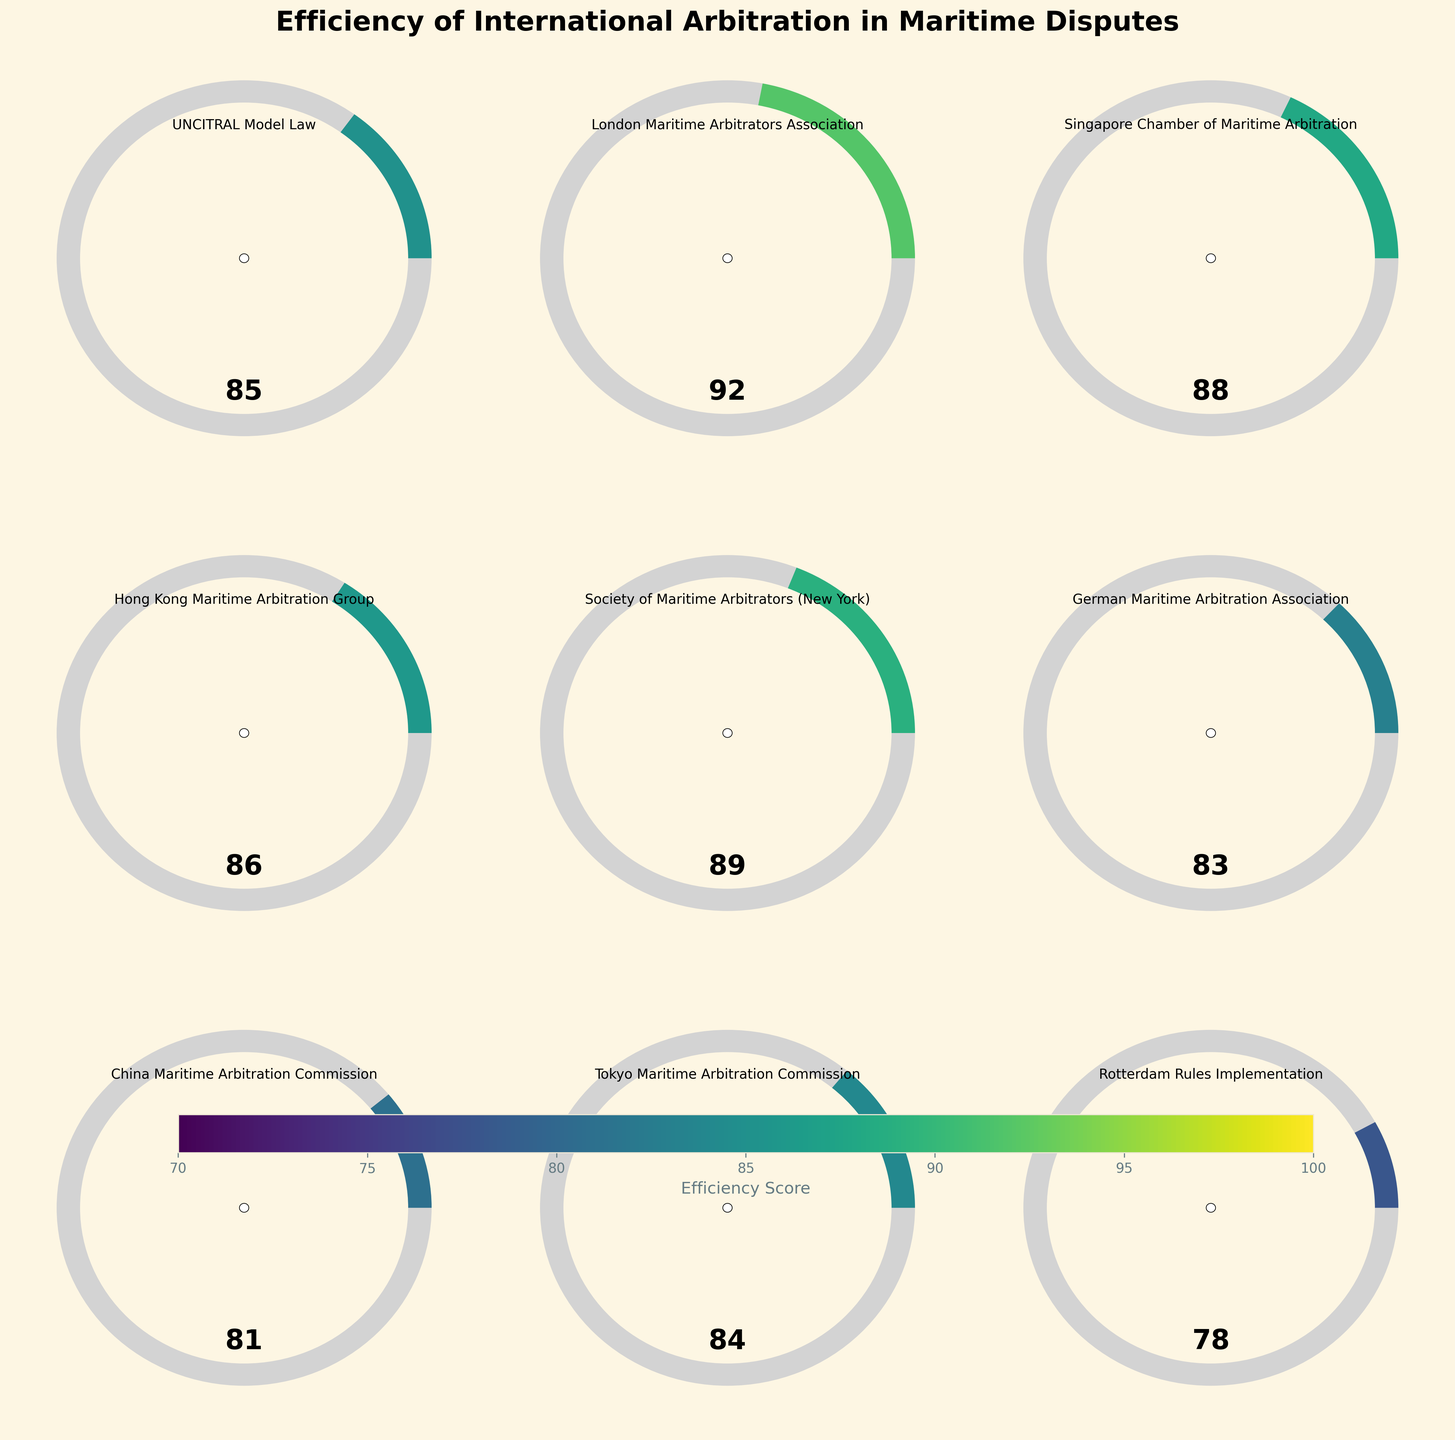What is the highest efficiency score in the figure? The London Maritime Arbitrators Association has the highest efficiency score. It is indicated by a value of 92 in one of the gauge charts.
Answer: 92 Which category has the lowest efficiency score? The Rotterdam Rules Implementation category has the lowest efficiency score, indicated by a value of 78 in its gauge chart.
Answer: Rotterdam Rules Implementation What is the title of the figure? The title of the figure is displayed at the top and reads "Efficiency of International Arbitration in Maritime Disputes".
Answer: Efficiency of International Arbitration in Maritime Disputes Which two categories have efficiency scores closest to each other? The efficiency scores for the Hong Kong Maritime Arbitration Group and the UNCITRAL Model Law are closest to each other, with scores of 86 and 85 respectively.
Answer: Hong Kong Maritime Arbitration Group, UNCITRAL Model Law What is the average efficiency score across all categories? Add all the efficiency scores (85 + 92 + 88 + 86 + 89 + 83 + 81 + 84 + 78) which equals 766, then divide by the number of categories (9) to get the average: 766 / 9 ≈ 85.11.
Answer: 85.11 How many categories have an efficiency score above 85? Count the number of gauge charts with a score greater than 85. They are: London Maritime Arbitrators Association (92), Singapore Chamber of Maritime Arbitration (88), Hong Kong Maritime Arbitration Group (86), and Society of Maritime Arbitrators (New York) (89).
Answer: 4 Which categories have an efficiency score of less than 80? Identify the gauge chart with scores below 80. The Rotterdam Rules Implementation has a score of 78.
Answer: Rotterdam Rules Implementation What is the difference between the highest and lowest efficiency scores? Subtract the lowest score (78 from Rotterdam Rules Implementation) from the highest score (92 from London Maritime Arbitrators Association): 92 - 78 = 14.
Answer: 14 Which categories are directly adjacent to each other in the subplot layout? To find the directly adjacent categories, observe those placed next to each other in rows and columns. For example, UNCITRAL Model Law is adjacent to London Maritime Arbitrators Association and Singapore Chamber of Maritime Arbitration in its row and column respectively.
Answer: UNCITRAL Model Law, London Maritime Arbitrators Association, Singapore Chamber of Maritime Arbitration What is the efficiency score of the German Maritime Arbitration Association? The gauge chart for the German Maritime Arbitration Association shows an efficiency score of 83.
Answer: 83 